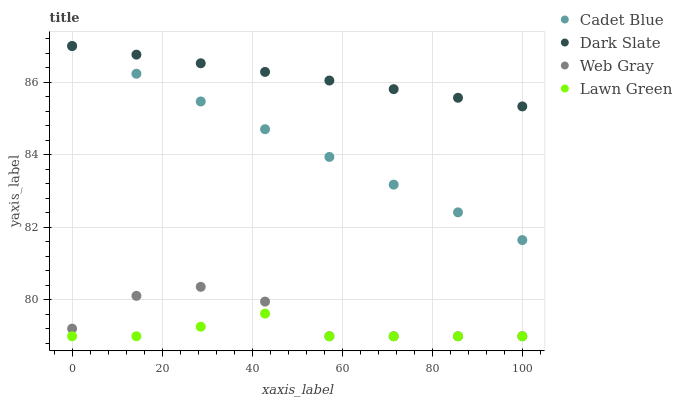Does Lawn Green have the minimum area under the curve?
Answer yes or no. Yes. Does Dark Slate have the maximum area under the curve?
Answer yes or no. Yes. Does Cadet Blue have the minimum area under the curve?
Answer yes or no. No. Does Cadet Blue have the maximum area under the curve?
Answer yes or no. No. Is Cadet Blue the smoothest?
Answer yes or no. Yes. Is Web Gray the roughest?
Answer yes or no. Yes. Is Web Gray the smoothest?
Answer yes or no. No. Is Cadet Blue the roughest?
Answer yes or no. No. Does Web Gray have the lowest value?
Answer yes or no. Yes. Does Cadet Blue have the lowest value?
Answer yes or no. No. Does Cadet Blue have the highest value?
Answer yes or no. Yes. Does Web Gray have the highest value?
Answer yes or no. No. Is Web Gray less than Cadet Blue?
Answer yes or no. Yes. Is Cadet Blue greater than Web Gray?
Answer yes or no. Yes. Does Web Gray intersect Lawn Green?
Answer yes or no. Yes. Is Web Gray less than Lawn Green?
Answer yes or no. No. Is Web Gray greater than Lawn Green?
Answer yes or no. No. Does Web Gray intersect Cadet Blue?
Answer yes or no. No. 